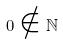Convert formula to latex. <formula><loc_0><loc_0><loc_500><loc_500>0 \notin \mathbb { N }</formula> 